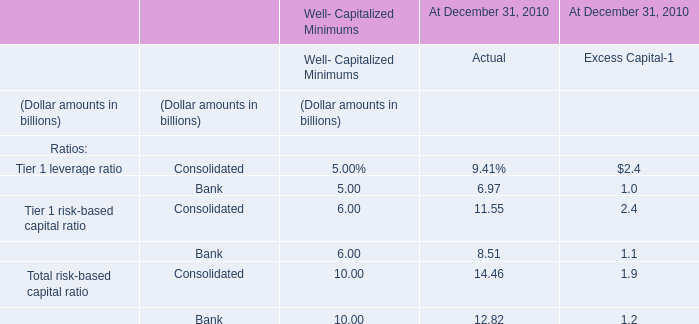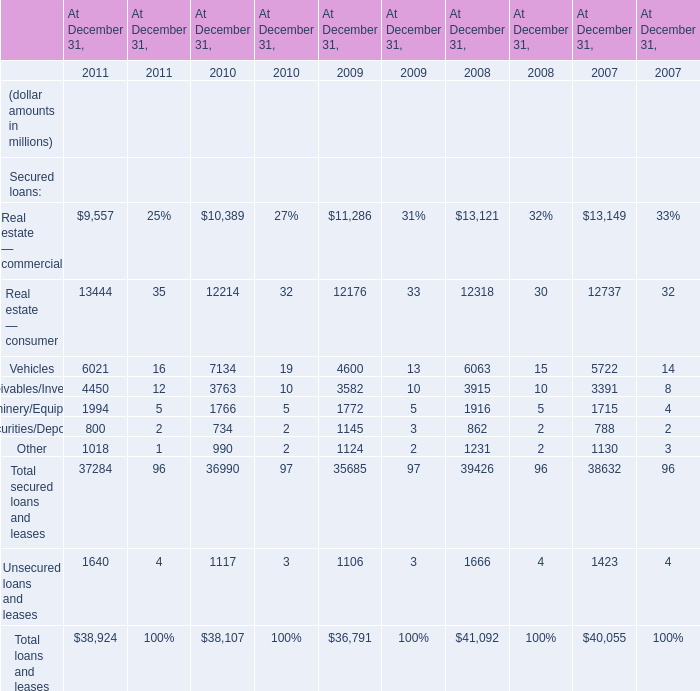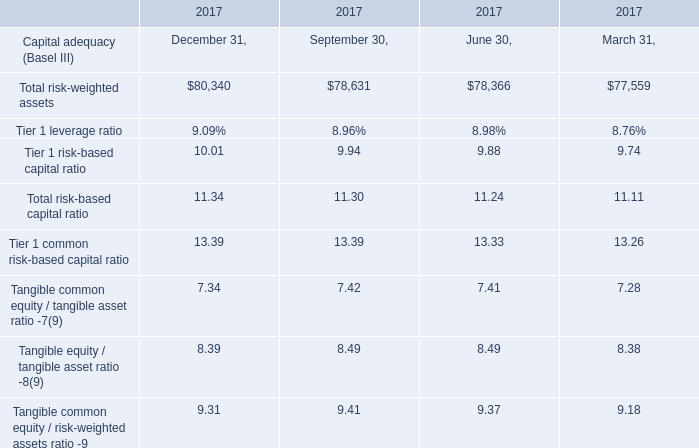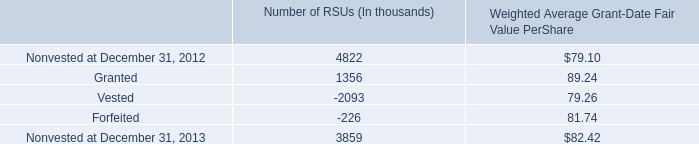in 2013 what was the percentage change in the nonvested rsus 
Computations: ((3859 - 4822) / 4822)
Answer: -0.19971. 